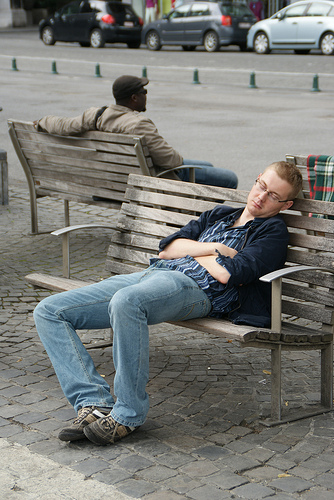<image>
Is there a man in front of the man? Yes. The man is positioned in front of the man, appearing closer to the camera viewpoint. 